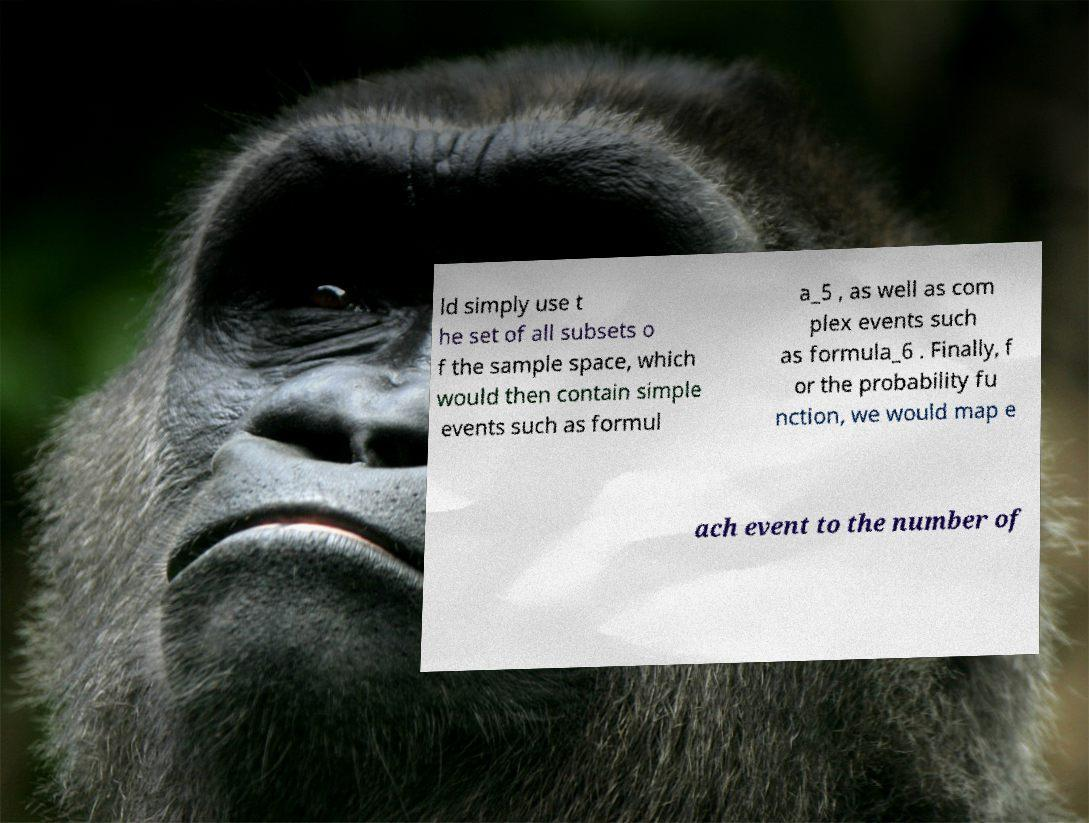There's text embedded in this image that I need extracted. Can you transcribe it verbatim? ld simply use t he set of all subsets o f the sample space, which would then contain simple events such as formul a_5 , as well as com plex events such as formula_6 . Finally, f or the probability fu nction, we would map e ach event to the number of 